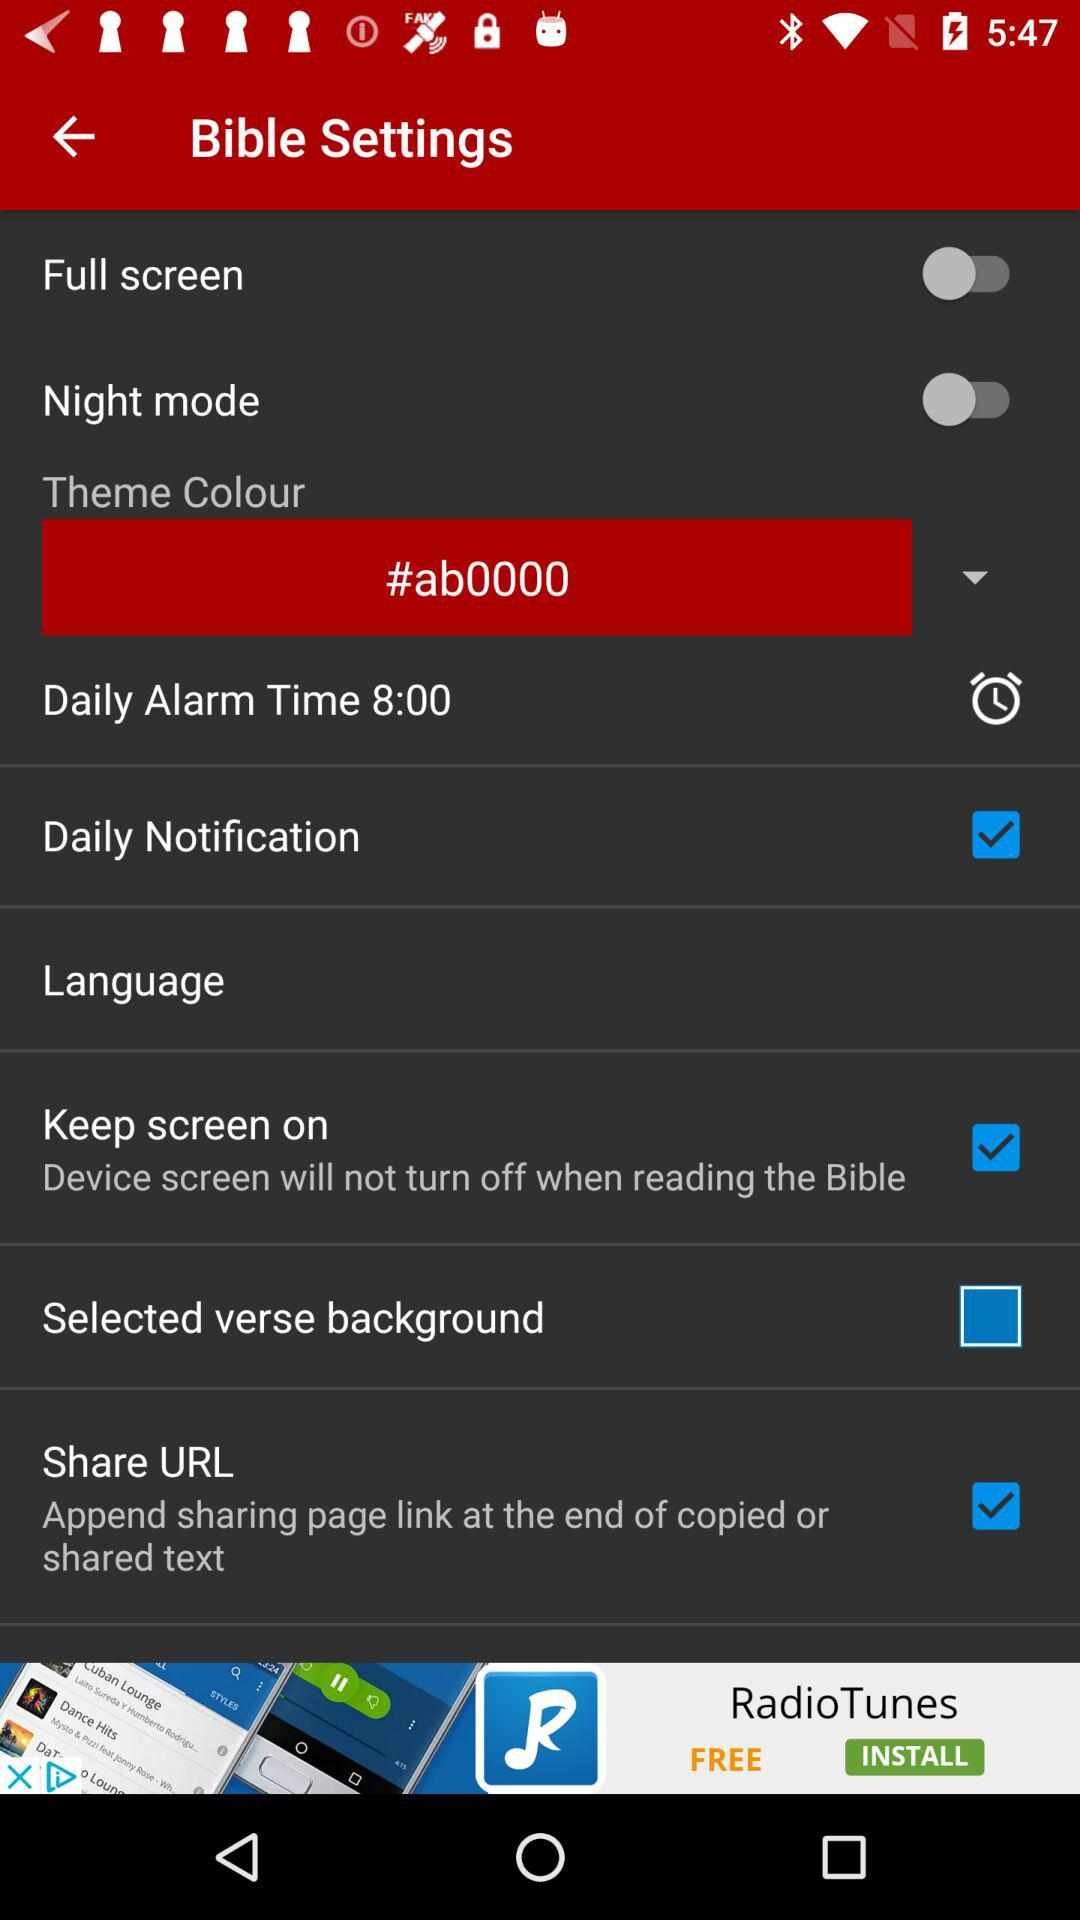What is the status of "Daily Notification"? The status is "on". 